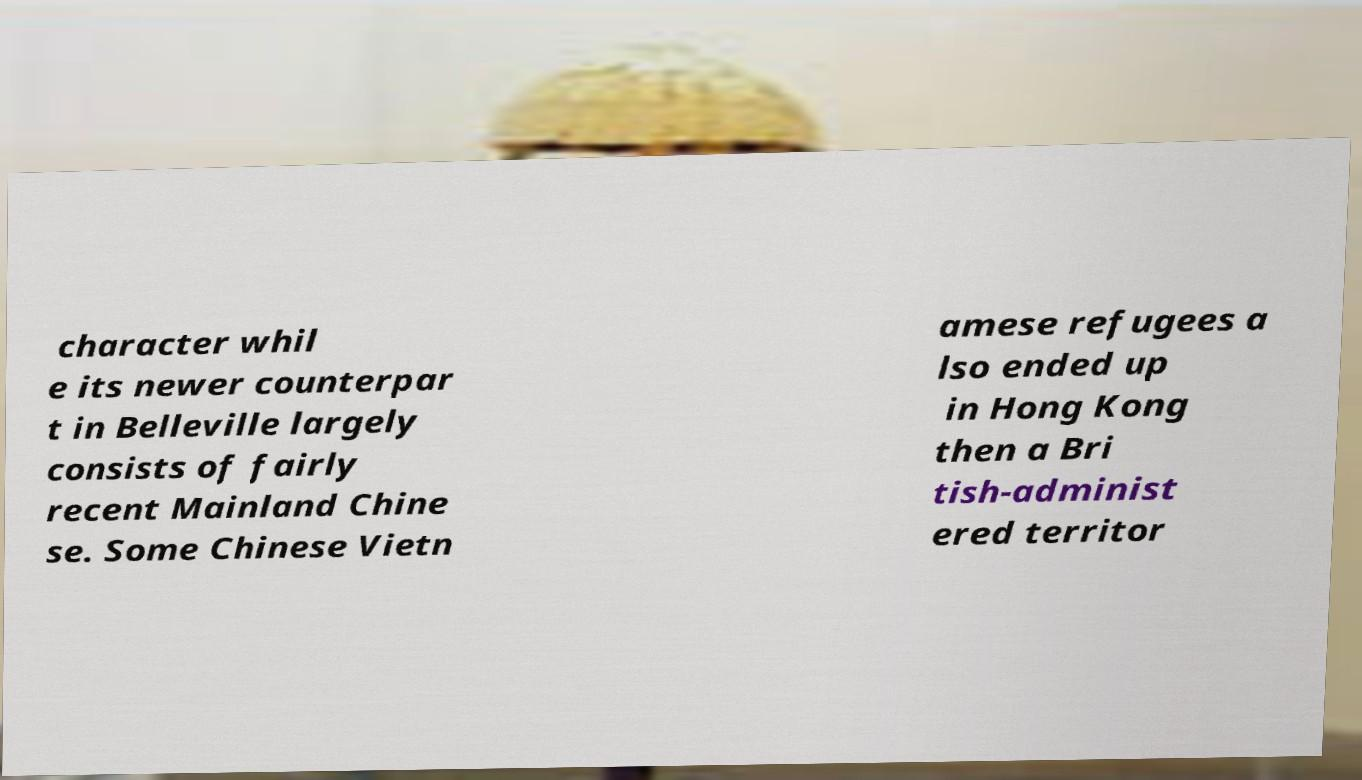Could you assist in decoding the text presented in this image and type it out clearly? character whil e its newer counterpar t in Belleville largely consists of fairly recent Mainland Chine se. Some Chinese Vietn amese refugees a lso ended up in Hong Kong then a Bri tish-administ ered territor 